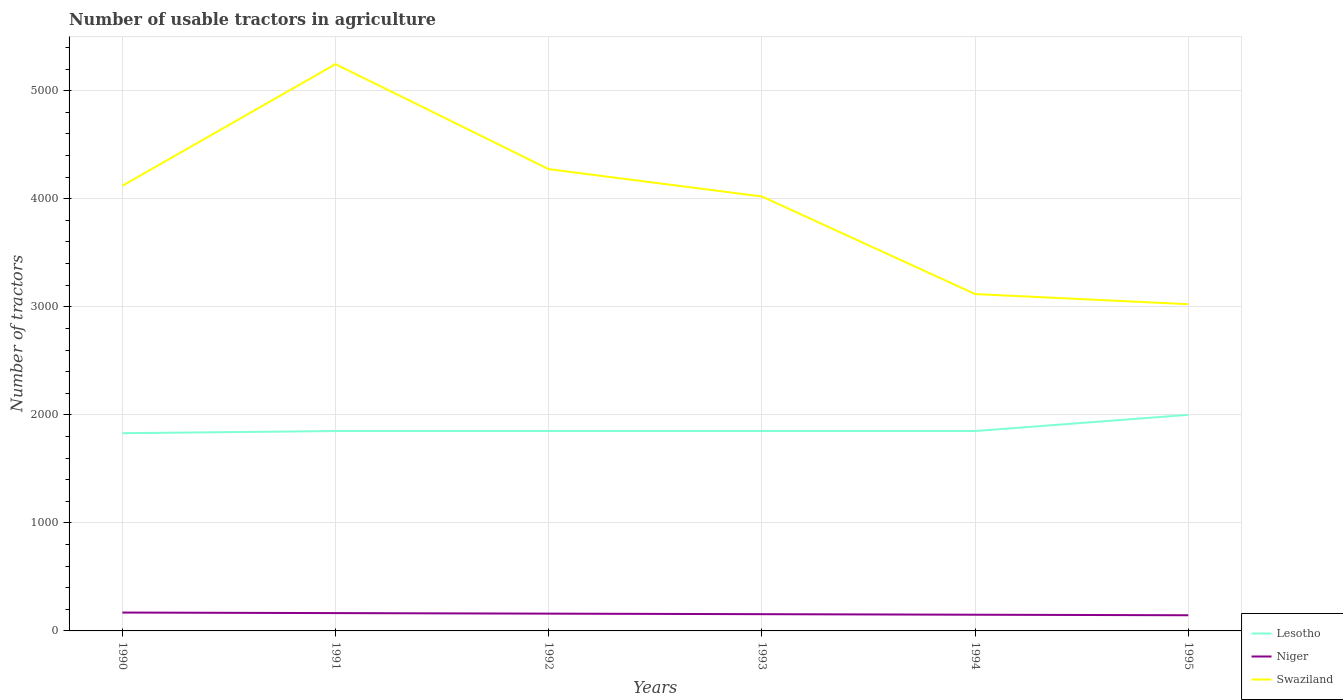How many different coloured lines are there?
Give a very brief answer. 3. Across all years, what is the maximum number of usable tractors in agriculture in Niger?
Your response must be concise. 145. In which year was the number of usable tractors in agriculture in Swaziland maximum?
Make the answer very short. 1995. What is the total number of usable tractors in agriculture in Swaziland in the graph?
Offer a very short reply. 972. What is the difference between the highest and the second highest number of usable tractors in agriculture in Niger?
Keep it short and to the point. 25. What is the difference between the highest and the lowest number of usable tractors in agriculture in Swaziland?
Provide a short and direct response. 4. Is the number of usable tractors in agriculture in Niger strictly greater than the number of usable tractors in agriculture in Swaziland over the years?
Ensure brevity in your answer.  Yes. How many lines are there?
Provide a succinct answer. 3. Does the graph contain grids?
Make the answer very short. Yes. Where does the legend appear in the graph?
Offer a terse response. Bottom right. How are the legend labels stacked?
Offer a very short reply. Vertical. What is the title of the graph?
Your answer should be very brief. Number of usable tractors in agriculture. What is the label or title of the Y-axis?
Offer a very short reply. Number of tractors. What is the Number of tractors of Lesotho in 1990?
Provide a short and direct response. 1830. What is the Number of tractors of Niger in 1990?
Your response must be concise. 170. What is the Number of tractors in Swaziland in 1990?
Your answer should be very brief. 4120. What is the Number of tractors of Lesotho in 1991?
Offer a very short reply. 1850. What is the Number of tractors in Niger in 1991?
Your answer should be compact. 165. What is the Number of tractors in Swaziland in 1991?
Your answer should be compact. 5246. What is the Number of tractors in Lesotho in 1992?
Your response must be concise. 1850. What is the Number of tractors in Niger in 1992?
Provide a succinct answer. 160. What is the Number of tractors in Swaziland in 1992?
Make the answer very short. 4274. What is the Number of tractors of Lesotho in 1993?
Your answer should be very brief. 1850. What is the Number of tractors in Niger in 1993?
Provide a short and direct response. 155. What is the Number of tractors of Swaziland in 1993?
Offer a very short reply. 4021. What is the Number of tractors in Lesotho in 1994?
Provide a short and direct response. 1850. What is the Number of tractors of Niger in 1994?
Give a very brief answer. 150. What is the Number of tractors of Swaziland in 1994?
Your answer should be compact. 3118. What is the Number of tractors in Lesotho in 1995?
Provide a succinct answer. 2000. What is the Number of tractors in Niger in 1995?
Give a very brief answer. 145. What is the Number of tractors of Swaziland in 1995?
Your answer should be very brief. 3024. Across all years, what is the maximum Number of tractors of Lesotho?
Ensure brevity in your answer.  2000. Across all years, what is the maximum Number of tractors of Niger?
Provide a short and direct response. 170. Across all years, what is the maximum Number of tractors in Swaziland?
Offer a very short reply. 5246. Across all years, what is the minimum Number of tractors of Lesotho?
Keep it short and to the point. 1830. Across all years, what is the minimum Number of tractors in Niger?
Provide a short and direct response. 145. Across all years, what is the minimum Number of tractors in Swaziland?
Offer a very short reply. 3024. What is the total Number of tractors in Lesotho in the graph?
Give a very brief answer. 1.12e+04. What is the total Number of tractors of Niger in the graph?
Keep it short and to the point. 945. What is the total Number of tractors of Swaziland in the graph?
Give a very brief answer. 2.38e+04. What is the difference between the Number of tractors in Lesotho in 1990 and that in 1991?
Ensure brevity in your answer.  -20. What is the difference between the Number of tractors of Swaziland in 1990 and that in 1991?
Your answer should be compact. -1126. What is the difference between the Number of tractors in Niger in 1990 and that in 1992?
Keep it short and to the point. 10. What is the difference between the Number of tractors of Swaziland in 1990 and that in 1992?
Your response must be concise. -154. What is the difference between the Number of tractors of Niger in 1990 and that in 1993?
Provide a succinct answer. 15. What is the difference between the Number of tractors of Swaziland in 1990 and that in 1994?
Keep it short and to the point. 1002. What is the difference between the Number of tractors of Lesotho in 1990 and that in 1995?
Ensure brevity in your answer.  -170. What is the difference between the Number of tractors in Niger in 1990 and that in 1995?
Offer a terse response. 25. What is the difference between the Number of tractors in Swaziland in 1990 and that in 1995?
Make the answer very short. 1096. What is the difference between the Number of tractors in Lesotho in 1991 and that in 1992?
Your answer should be compact. 0. What is the difference between the Number of tractors of Swaziland in 1991 and that in 1992?
Your response must be concise. 972. What is the difference between the Number of tractors in Swaziland in 1991 and that in 1993?
Provide a succinct answer. 1225. What is the difference between the Number of tractors in Lesotho in 1991 and that in 1994?
Offer a very short reply. 0. What is the difference between the Number of tractors of Niger in 1991 and that in 1994?
Ensure brevity in your answer.  15. What is the difference between the Number of tractors of Swaziland in 1991 and that in 1994?
Give a very brief answer. 2128. What is the difference between the Number of tractors in Lesotho in 1991 and that in 1995?
Offer a very short reply. -150. What is the difference between the Number of tractors of Swaziland in 1991 and that in 1995?
Provide a succinct answer. 2222. What is the difference between the Number of tractors in Lesotho in 1992 and that in 1993?
Your answer should be compact. 0. What is the difference between the Number of tractors in Niger in 1992 and that in 1993?
Provide a succinct answer. 5. What is the difference between the Number of tractors of Swaziland in 1992 and that in 1993?
Your answer should be very brief. 253. What is the difference between the Number of tractors in Swaziland in 1992 and that in 1994?
Provide a succinct answer. 1156. What is the difference between the Number of tractors of Lesotho in 1992 and that in 1995?
Ensure brevity in your answer.  -150. What is the difference between the Number of tractors of Swaziland in 1992 and that in 1995?
Your response must be concise. 1250. What is the difference between the Number of tractors in Lesotho in 1993 and that in 1994?
Your response must be concise. 0. What is the difference between the Number of tractors of Swaziland in 1993 and that in 1994?
Offer a very short reply. 903. What is the difference between the Number of tractors in Lesotho in 1993 and that in 1995?
Offer a terse response. -150. What is the difference between the Number of tractors of Niger in 1993 and that in 1995?
Provide a short and direct response. 10. What is the difference between the Number of tractors in Swaziland in 1993 and that in 1995?
Your answer should be compact. 997. What is the difference between the Number of tractors of Lesotho in 1994 and that in 1995?
Offer a very short reply. -150. What is the difference between the Number of tractors of Swaziland in 1994 and that in 1995?
Provide a succinct answer. 94. What is the difference between the Number of tractors in Lesotho in 1990 and the Number of tractors in Niger in 1991?
Keep it short and to the point. 1665. What is the difference between the Number of tractors in Lesotho in 1990 and the Number of tractors in Swaziland in 1991?
Give a very brief answer. -3416. What is the difference between the Number of tractors of Niger in 1990 and the Number of tractors of Swaziland in 1991?
Ensure brevity in your answer.  -5076. What is the difference between the Number of tractors of Lesotho in 1990 and the Number of tractors of Niger in 1992?
Offer a terse response. 1670. What is the difference between the Number of tractors in Lesotho in 1990 and the Number of tractors in Swaziland in 1992?
Provide a succinct answer. -2444. What is the difference between the Number of tractors in Niger in 1990 and the Number of tractors in Swaziland in 1992?
Ensure brevity in your answer.  -4104. What is the difference between the Number of tractors of Lesotho in 1990 and the Number of tractors of Niger in 1993?
Your response must be concise. 1675. What is the difference between the Number of tractors of Lesotho in 1990 and the Number of tractors of Swaziland in 1993?
Your answer should be compact. -2191. What is the difference between the Number of tractors in Niger in 1990 and the Number of tractors in Swaziland in 1993?
Your answer should be compact. -3851. What is the difference between the Number of tractors in Lesotho in 1990 and the Number of tractors in Niger in 1994?
Offer a terse response. 1680. What is the difference between the Number of tractors in Lesotho in 1990 and the Number of tractors in Swaziland in 1994?
Provide a short and direct response. -1288. What is the difference between the Number of tractors of Niger in 1990 and the Number of tractors of Swaziland in 1994?
Keep it short and to the point. -2948. What is the difference between the Number of tractors of Lesotho in 1990 and the Number of tractors of Niger in 1995?
Offer a very short reply. 1685. What is the difference between the Number of tractors in Lesotho in 1990 and the Number of tractors in Swaziland in 1995?
Provide a short and direct response. -1194. What is the difference between the Number of tractors of Niger in 1990 and the Number of tractors of Swaziland in 1995?
Offer a very short reply. -2854. What is the difference between the Number of tractors in Lesotho in 1991 and the Number of tractors in Niger in 1992?
Your response must be concise. 1690. What is the difference between the Number of tractors of Lesotho in 1991 and the Number of tractors of Swaziland in 1992?
Your answer should be very brief. -2424. What is the difference between the Number of tractors in Niger in 1991 and the Number of tractors in Swaziland in 1992?
Make the answer very short. -4109. What is the difference between the Number of tractors in Lesotho in 1991 and the Number of tractors in Niger in 1993?
Your response must be concise. 1695. What is the difference between the Number of tractors of Lesotho in 1991 and the Number of tractors of Swaziland in 1993?
Provide a succinct answer. -2171. What is the difference between the Number of tractors in Niger in 1991 and the Number of tractors in Swaziland in 1993?
Offer a very short reply. -3856. What is the difference between the Number of tractors of Lesotho in 1991 and the Number of tractors of Niger in 1994?
Provide a succinct answer. 1700. What is the difference between the Number of tractors in Lesotho in 1991 and the Number of tractors in Swaziland in 1994?
Your response must be concise. -1268. What is the difference between the Number of tractors of Niger in 1991 and the Number of tractors of Swaziland in 1994?
Your answer should be very brief. -2953. What is the difference between the Number of tractors of Lesotho in 1991 and the Number of tractors of Niger in 1995?
Make the answer very short. 1705. What is the difference between the Number of tractors of Lesotho in 1991 and the Number of tractors of Swaziland in 1995?
Give a very brief answer. -1174. What is the difference between the Number of tractors in Niger in 1991 and the Number of tractors in Swaziland in 1995?
Ensure brevity in your answer.  -2859. What is the difference between the Number of tractors in Lesotho in 1992 and the Number of tractors in Niger in 1993?
Offer a terse response. 1695. What is the difference between the Number of tractors in Lesotho in 1992 and the Number of tractors in Swaziland in 1993?
Ensure brevity in your answer.  -2171. What is the difference between the Number of tractors of Niger in 1992 and the Number of tractors of Swaziland in 1993?
Offer a very short reply. -3861. What is the difference between the Number of tractors of Lesotho in 1992 and the Number of tractors of Niger in 1994?
Keep it short and to the point. 1700. What is the difference between the Number of tractors of Lesotho in 1992 and the Number of tractors of Swaziland in 1994?
Your response must be concise. -1268. What is the difference between the Number of tractors in Niger in 1992 and the Number of tractors in Swaziland in 1994?
Provide a succinct answer. -2958. What is the difference between the Number of tractors of Lesotho in 1992 and the Number of tractors of Niger in 1995?
Offer a very short reply. 1705. What is the difference between the Number of tractors in Lesotho in 1992 and the Number of tractors in Swaziland in 1995?
Your response must be concise. -1174. What is the difference between the Number of tractors in Niger in 1992 and the Number of tractors in Swaziland in 1995?
Provide a short and direct response. -2864. What is the difference between the Number of tractors in Lesotho in 1993 and the Number of tractors in Niger in 1994?
Make the answer very short. 1700. What is the difference between the Number of tractors of Lesotho in 1993 and the Number of tractors of Swaziland in 1994?
Provide a short and direct response. -1268. What is the difference between the Number of tractors of Niger in 1993 and the Number of tractors of Swaziland in 1994?
Your answer should be compact. -2963. What is the difference between the Number of tractors in Lesotho in 1993 and the Number of tractors in Niger in 1995?
Give a very brief answer. 1705. What is the difference between the Number of tractors in Lesotho in 1993 and the Number of tractors in Swaziland in 1995?
Provide a succinct answer. -1174. What is the difference between the Number of tractors of Niger in 1993 and the Number of tractors of Swaziland in 1995?
Offer a terse response. -2869. What is the difference between the Number of tractors in Lesotho in 1994 and the Number of tractors in Niger in 1995?
Offer a terse response. 1705. What is the difference between the Number of tractors of Lesotho in 1994 and the Number of tractors of Swaziland in 1995?
Offer a very short reply. -1174. What is the difference between the Number of tractors in Niger in 1994 and the Number of tractors in Swaziland in 1995?
Your answer should be compact. -2874. What is the average Number of tractors in Lesotho per year?
Your response must be concise. 1871.67. What is the average Number of tractors of Niger per year?
Ensure brevity in your answer.  157.5. What is the average Number of tractors in Swaziland per year?
Ensure brevity in your answer.  3967.17. In the year 1990, what is the difference between the Number of tractors in Lesotho and Number of tractors in Niger?
Offer a very short reply. 1660. In the year 1990, what is the difference between the Number of tractors in Lesotho and Number of tractors in Swaziland?
Make the answer very short. -2290. In the year 1990, what is the difference between the Number of tractors of Niger and Number of tractors of Swaziland?
Offer a very short reply. -3950. In the year 1991, what is the difference between the Number of tractors in Lesotho and Number of tractors in Niger?
Give a very brief answer. 1685. In the year 1991, what is the difference between the Number of tractors in Lesotho and Number of tractors in Swaziland?
Offer a terse response. -3396. In the year 1991, what is the difference between the Number of tractors in Niger and Number of tractors in Swaziland?
Offer a very short reply. -5081. In the year 1992, what is the difference between the Number of tractors of Lesotho and Number of tractors of Niger?
Keep it short and to the point. 1690. In the year 1992, what is the difference between the Number of tractors of Lesotho and Number of tractors of Swaziland?
Give a very brief answer. -2424. In the year 1992, what is the difference between the Number of tractors of Niger and Number of tractors of Swaziland?
Your answer should be compact. -4114. In the year 1993, what is the difference between the Number of tractors in Lesotho and Number of tractors in Niger?
Offer a terse response. 1695. In the year 1993, what is the difference between the Number of tractors in Lesotho and Number of tractors in Swaziland?
Offer a very short reply. -2171. In the year 1993, what is the difference between the Number of tractors in Niger and Number of tractors in Swaziland?
Offer a terse response. -3866. In the year 1994, what is the difference between the Number of tractors of Lesotho and Number of tractors of Niger?
Your answer should be compact. 1700. In the year 1994, what is the difference between the Number of tractors of Lesotho and Number of tractors of Swaziland?
Provide a succinct answer. -1268. In the year 1994, what is the difference between the Number of tractors in Niger and Number of tractors in Swaziland?
Your response must be concise. -2968. In the year 1995, what is the difference between the Number of tractors in Lesotho and Number of tractors in Niger?
Provide a short and direct response. 1855. In the year 1995, what is the difference between the Number of tractors of Lesotho and Number of tractors of Swaziland?
Your answer should be compact. -1024. In the year 1995, what is the difference between the Number of tractors of Niger and Number of tractors of Swaziland?
Your response must be concise. -2879. What is the ratio of the Number of tractors of Niger in 1990 to that in 1991?
Make the answer very short. 1.03. What is the ratio of the Number of tractors in Swaziland in 1990 to that in 1991?
Give a very brief answer. 0.79. What is the ratio of the Number of tractors of Lesotho in 1990 to that in 1993?
Give a very brief answer. 0.99. What is the ratio of the Number of tractors in Niger in 1990 to that in 1993?
Offer a terse response. 1.1. What is the ratio of the Number of tractors in Swaziland in 1990 to that in 1993?
Make the answer very short. 1.02. What is the ratio of the Number of tractors in Lesotho in 1990 to that in 1994?
Ensure brevity in your answer.  0.99. What is the ratio of the Number of tractors of Niger in 1990 to that in 1994?
Your answer should be compact. 1.13. What is the ratio of the Number of tractors of Swaziland in 1990 to that in 1994?
Give a very brief answer. 1.32. What is the ratio of the Number of tractors in Lesotho in 1990 to that in 1995?
Give a very brief answer. 0.92. What is the ratio of the Number of tractors in Niger in 1990 to that in 1995?
Provide a short and direct response. 1.17. What is the ratio of the Number of tractors of Swaziland in 1990 to that in 1995?
Provide a short and direct response. 1.36. What is the ratio of the Number of tractors of Lesotho in 1991 to that in 1992?
Ensure brevity in your answer.  1. What is the ratio of the Number of tractors in Niger in 1991 to that in 1992?
Make the answer very short. 1.03. What is the ratio of the Number of tractors of Swaziland in 1991 to that in 1992?
Ensure brevity in your answer.  1.23. What is the ratio of the Number of tractors of Niger in 1991 to that in 1993?
Make the answer very short. 1.06. What is the ratio of the Number of tractors in Swaziland in 1991 to that in 1993?
Your answer should be compact. 1.3. What is the ratio of the Number of tractors of Niger in 1991 to that in 1994?
Provide a short and direct response. 1.1. What is the ratio of the Number of tractors of Swaziland in 1991 to that in 1994?
Your answer should be compact. 1.68. What is the ratio of the Number of tractors of Lesotho in 1991 to that in 1995?
Ensure brevity in your answer.  0.93. What is the ratio of the Number of tractors of Niger in 1991 to that in 1995?
Offer a terse response. 1.14. What is the ratio of the Number of tractors of Swaziland in 1991 to that in 1995?
Ensure brevity in your answer.  1.73. What is the ratio of the Number of tractors in Lesotho in 1992 to that in 1993?
Offer a terse response. 1. What is the ratio of the Number of tractors in Niger in 1992 to that in 1993?
Provide a succinct answer. 1.03. What is the ratio of the Number of tractors of Swaziland in 1992 to that in 1993?
Offer a very short reply. 1.06. What is the ratio of the Number of tractors of Niger in 1992 to that in 1994?
Make the answer very short. 1.07. What is the ratio of the Number of tractors in Swaziland in 1992 to that in 1994?
Your response must be concise. 1.37. What is the ratio of the Number of tractors in Lesotho in 1992 to that in 1995?
Your response must be concise. 0.93. What is the ratio of the Number of tractors in Niger in 1992 to that in 1995?
Provide a succinct answer. 1.1. What is the ratio of the Number of tractors of Swaziland in 1992 to that in 1995?
Make the answer very short. 1.41. What is the ratio of the Number of tractors of Lesotho in 1993 to that in 1994?
Make the answer very short. 1. What is the ratio of the Number of tractors in Niger in 1993 to that in 1994?
Offer a terse response. 1.03. What is the ratio of the Number of tractors of Swaziland in 1993 to that in 1994?
Offer a very short reply. 1.29. What is the ratio of the Number of tractors in Lesotho in 1993 to that in 1995?
Your answer should be compact. 0.93. What is the ratio of the Number of tractors of Niger in 1993 to that in 1995?
Provide a short and direct response. 1.07. What is the ratio of the Number of tractors in Swaziland in 1993 to that in 1995?
Provide a succinct answer. 1.33. What is the ratio of the Number of tractors of Lesotho in 1994 to that in 1995?
Make the answer very short. 0.93. What is the ratio of the Number of tractors in Niger in 1994 to that in 1995?
Keep it short and to the point. 1.03. What is the ratio of the Number of tractors of Swaziland in 1994 to that in 1995?
Provide a short and direct response. 1.03. What is the difference between the highest and the second highest Number of tractors of Lesotho?
Ensure brevity in your answer.  150. What is the difference between the highest and the second highest Number of tractors in Swaziland?
Give a very brief answer. 972. What is the difference between the highest and the lowest Number of tractors in Lesotho?
Keep it short and to the point. 170. What is the difference between the highest and the lowest Number of tractors of Swaziland?
Keep it short and to the point. 2222. 